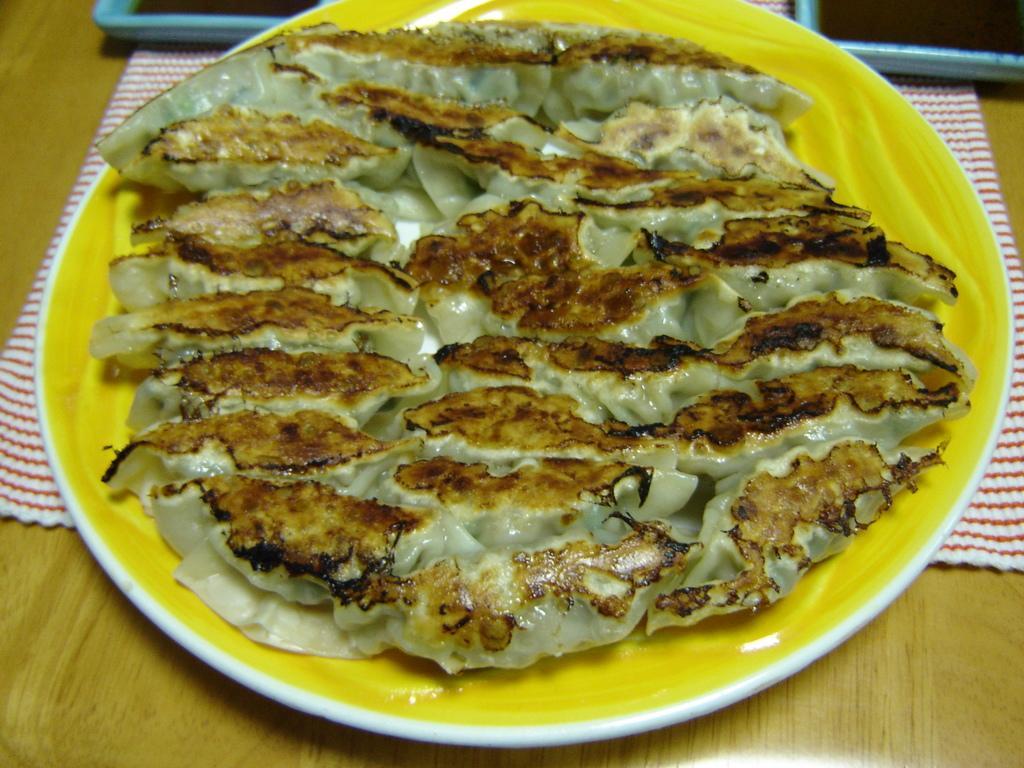Could you give a brief overview of what you see in this image? In this image there is a food item on a plate, the plate is the top of a table, beneath the planet there is a napkin, beside the plate there are two other plates. 